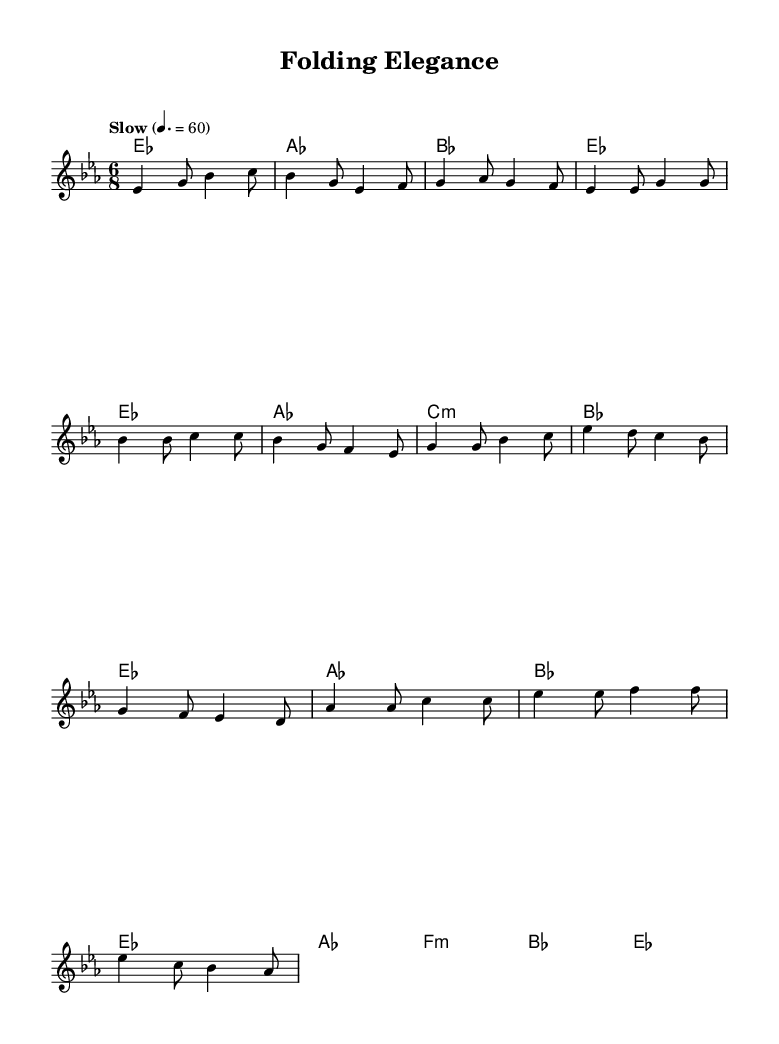What is the key signature of this music? The key signature is indicated at the beginning of the staff, and it shows three flats, which corresponds to E flat major or C minor.
Answer: E flat major What is the time signature of this music? The time signature is shown at the beginning of the staff, indicating a compound time with a division of 6 beats in a measure with an eighth note as the basic unit.
Answer: 6/8 What tempo marking is given in the music? The tempo marking is listed below the title indicating the speed of the piece, specifically saying "Slow" with a beat of 60 per minute.
Answer: Slow How many measures are in the verse section? Counting the measures designated for the verse section, there are a total of four measures before moving on to the chorus section.
Answer: Four What is the distinctive feature of the chorus compared to the verse? By analyzing the melody and harmonies, the chorus has a slightly different melodic contour and harmonic progression, which can be identified by the transition and rhythmic variation in the music.
Answer: Different melodic contour Which part of the music uses minor chords? By examining the harmony section, the bridge features a minor chord sequence, notably the F minor chord, which adds a contrasting emotional quality.
Answer: F minor What emotion does the bridge typically convey in a soulful ballad? The bridge often presents contrasting themes or intense emotions, which can be interpreted from the changes in harmony and melody, usually evoking feelings of longing or introspection.
Answer: Longing 